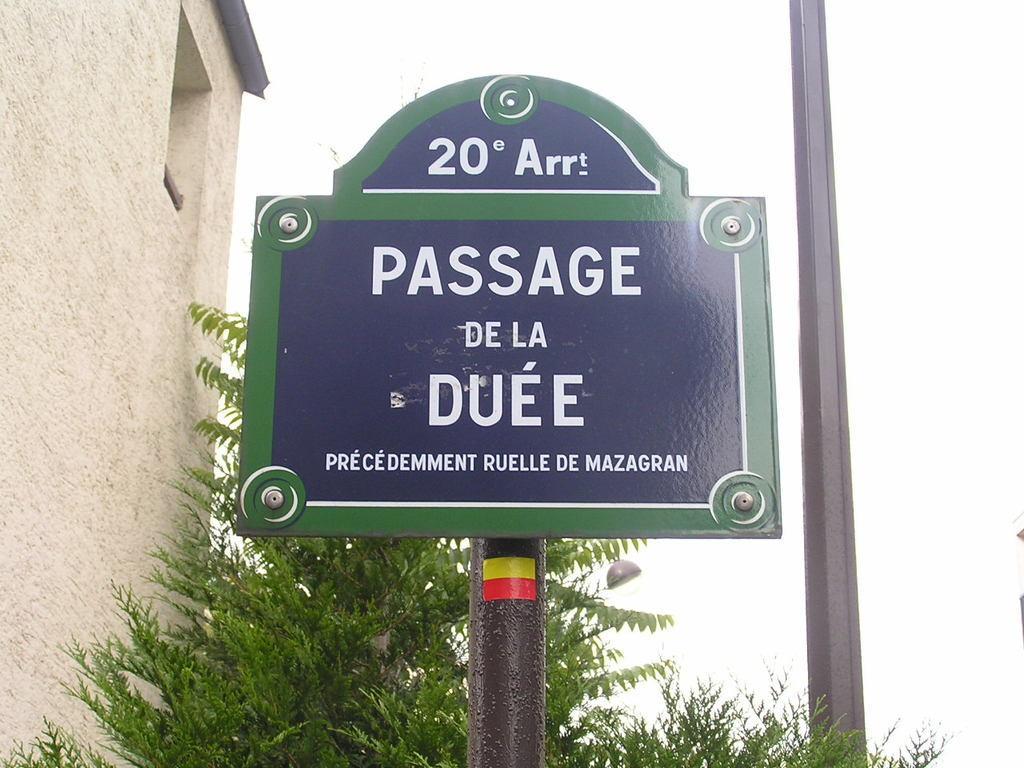In one or two sentences, can you explain what this image depicts? In this image, we can see a sign board with pole. Background we can see tree, wall, pillar. 